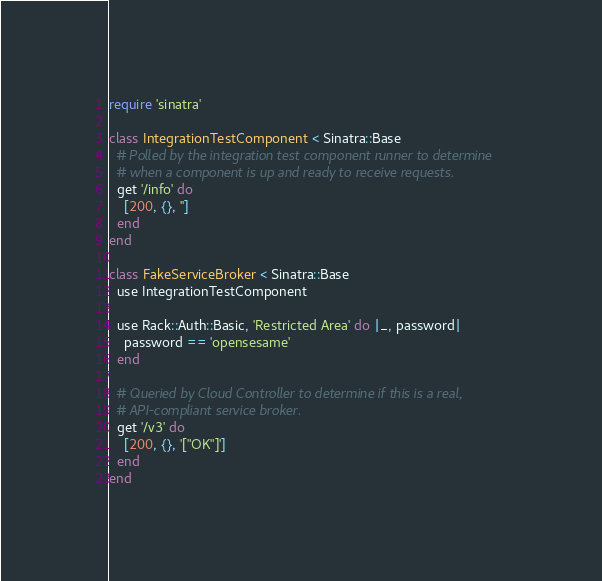<code> <loc_0><loc_0><loc_500><loc_500><_Ruby_>require 'sinatra'

class IntegrationTestComponent < Sinatra::Base
  # Polled by the integration test component runner to determine
  # when a component is up and ready to receive requests.
  get '/info' do
    [200, {}, '']
  end
end

class FakeServiceBroker < Sinatra::Base
  use IntegrationTestComponent

  use Rack::Auth::Basic, 'Restricted Area' do |_, password|
    password == 'opensesame'
  end

  # Queried by Cloud Controller to determine if this is a real,
  # API-compliant service broker.
  get '/v3' do
    [200, {}, '["OK"]']
  end
end
</code> 